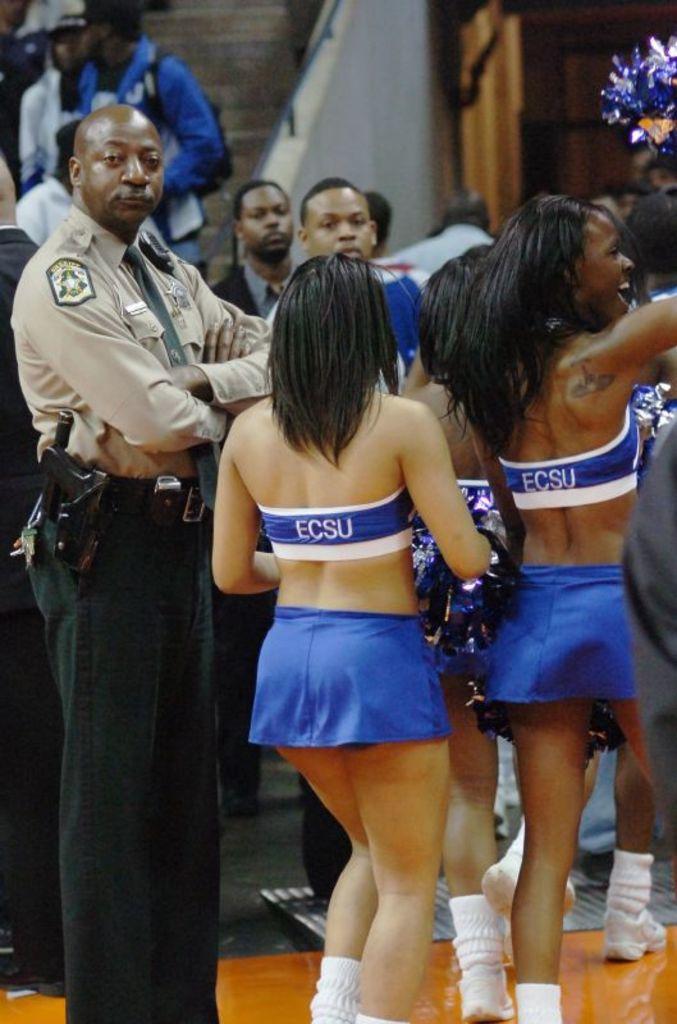Provide a one-sentence caption for the provided image. ECSU cheerleaders are on a basketball court during a game. 